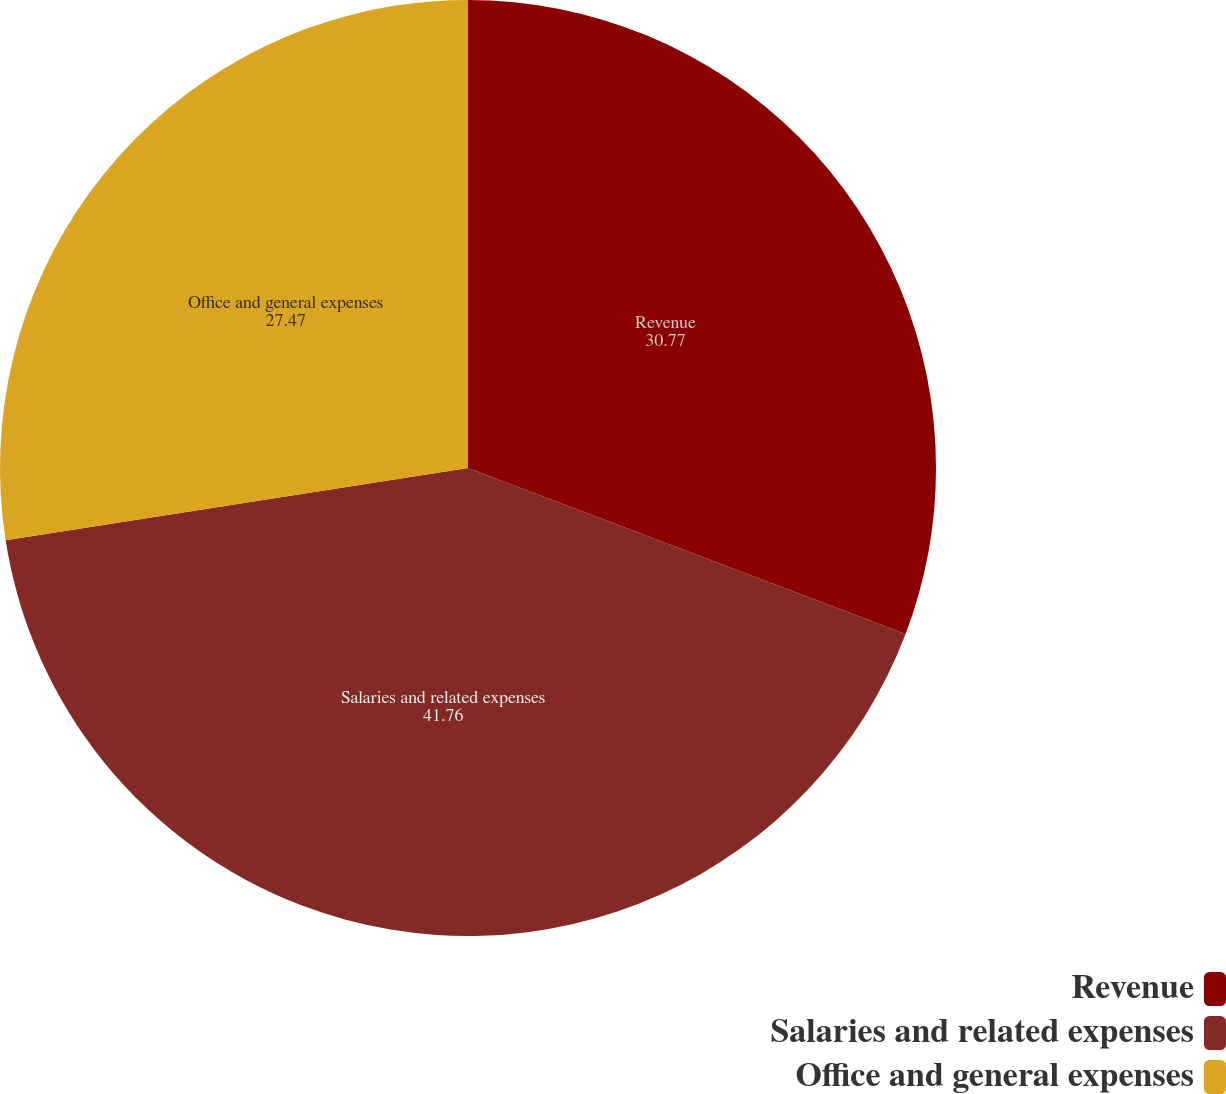Convert chart to OTSL. <chart><loc_0><loc_0><loc_500><loc_500><pie_chart><fcel>Revenue<fcel>Salaries and related expenses<fcel>Office and general expenses<nl><fcel>30.77%<fcel>41.76%<fcel>27.47%<nl></chart> 